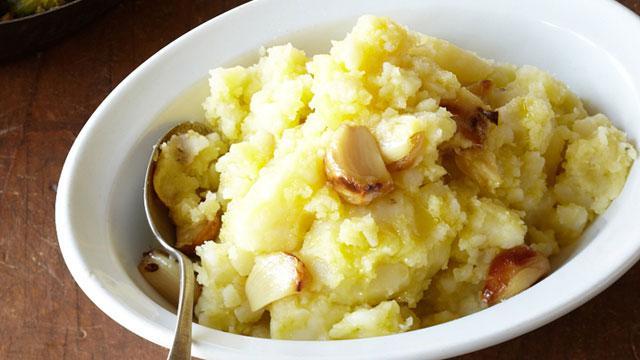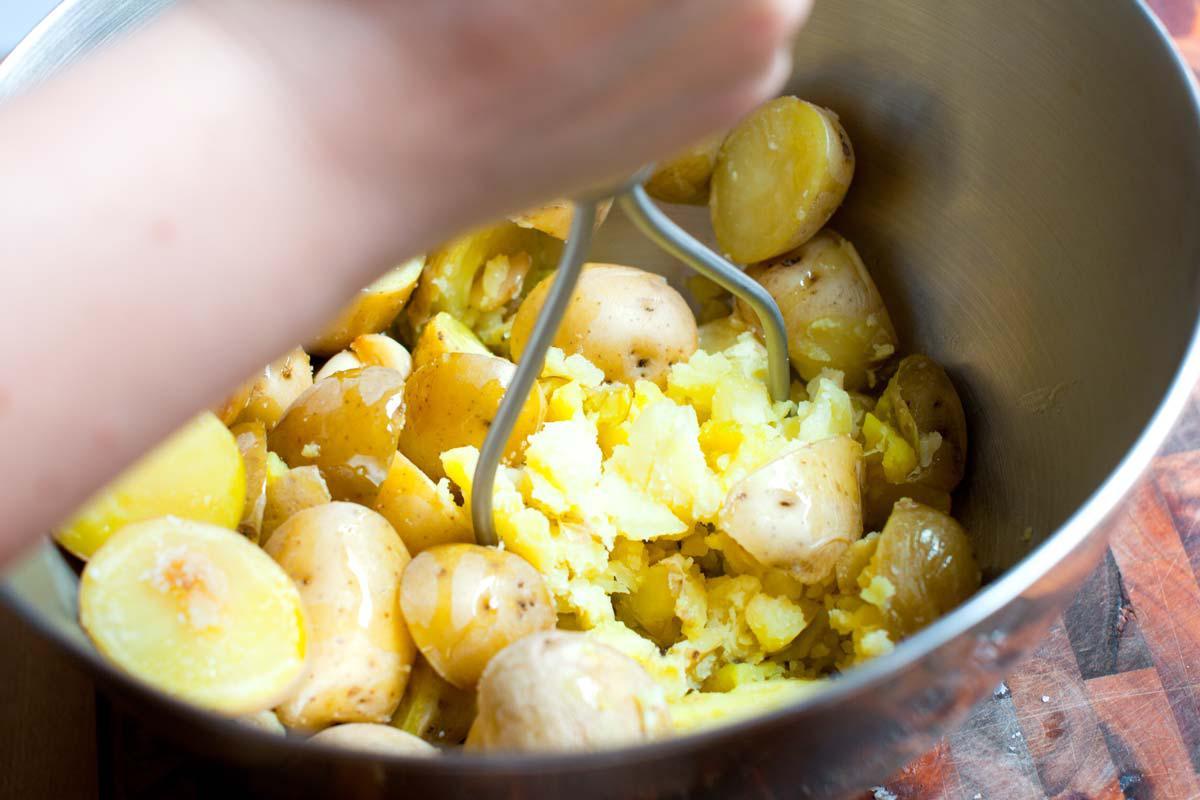The first image is the image on the left, the second image is the image on the right. Assess this claim about the two images: "The left and right image contains the same number of fully mashed potatoes bowls with spoons.". Correct or not? Answer yes or no. No. 